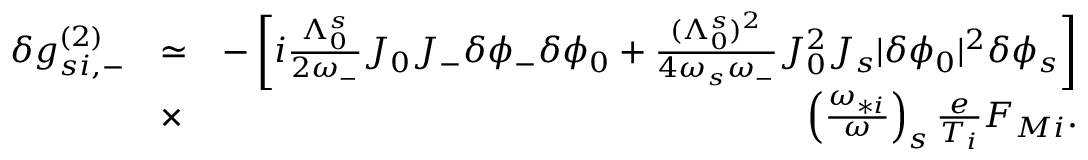Convert formula to latex. <formula><loc_0><loc_0><loc_500><loc_500>\begin{array} { r l r } { \delta g _ { s i , - } ^ { ( 2 ) } } & { \simeq } & { - \left [ i \frac { \Lambda _ { 0 } ^ { s } } { 2 \omega _ { - } } J _ { 0 } J _ { - } \delta \phi _ { - } \delta \phi _ { 0 } + \frac { ( \Lambda _ { 0 } ^ { s } ) ^ { 2 } } { 4 \omega _ { s } \omega _ { - } } J _ { 0 } ^ { 2 } J _ { s } | \delta \phi _ { 0 } | ^ { 2 } \delta \phi _ { s } \right ] } \\ & { \times } & { \left ( \frac { \omega _ { * i } } { \omega } \right ) _ { s } \frac { e } { T _ { i } } F _ { M i } . } \end{array}</formula> 